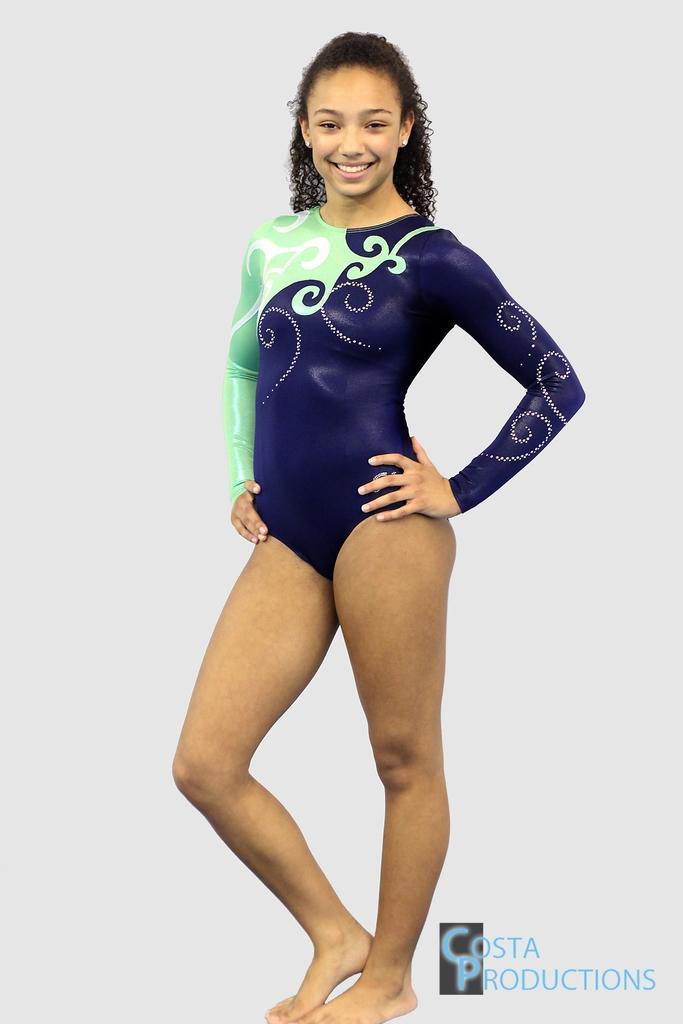How would you summarize this image in a sentence or two? In this image there is one women standing in middle of this image and she is smiling. There is one watermark at bottom right corner of this image. 